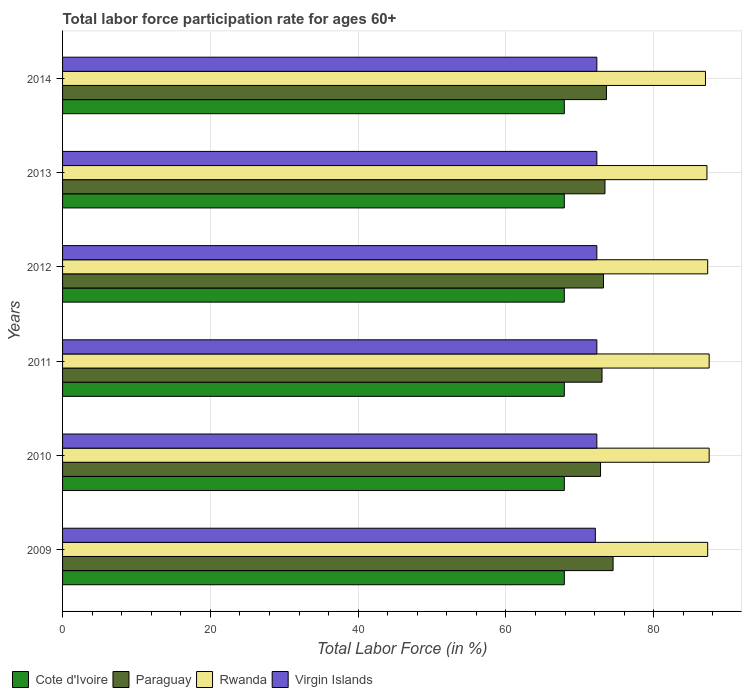Are the number of bars per tick equal to the number of legend labels?
Provide a succinct answer. Yes. Are the number of bars on each tick of the Y-axis equal?
Your answer should be very brief. Yes. In how many cases, is the number of bars for a given year not equal to the number of legend labels?
Give a very brief answer. 0. What is the labor force participation rate in Virgin Islands in 2011?
Your response must be concise. 72.3. Across all years, what is the maximum labor force participation rate in Rwanda?
Provide a short and direct response. 87.5. Across all years, what is the minimum labor force participation rate in Paraguay?
Your answer should be very brief. 72.8. In which year was the labor force participation rate in Virgin Islands maximum?
Provide a succinct answer. 2010. What is the total labor force participation rate in Cote d'Ivoire in the graph?
Your answer should be very brief. 407.4. What is the difference between the labor force participation rate in Cote d'Ivoire in 2009 and that in 2012?
Your response must be concise. 0. What is the difference between the labor force participation rate in Cote d'Ivoire in 2010 and the labor force participation rate in Rwanda in 2012?
Make the answer very short. -19.4. What is the average labor force participation rate in Virgin Islands per year?
Your answer should be compact. 72.27. In the year 2011, what is the difference between the labor force participation rate in Cote d'Ivoire and labor force participation rate in Paraguay?
Provide a short and direct response. -5.1. In how many years, is the labor force participation rate in Cote d'Ivoire greater than 8 %?
Make the answer very short. 6. What is the ratio of the labor force participation rate in Rwanda in 2012 to that in 2014?
Your answer should be compact. 1. What is the difference between the highest and the lowest labor force participation rate in Cote d'Ivoire?
Provide a short and direct response. 0. In how many years, is the labor force participation rate in Virgin Islands greater than the average labor force participation rate in Virgin Islands taken over all years?
Provide a succinct answer. 5. Is the sum of the labor force participation rate in Virgin Islands in 2010 and 2013 greater than the maximum labor force participation rate in Rwanda across all years?
Give a very brief answer. Yes. What does the 2nd bar from the top in 2014 represents?
Offer a very short reply. Rwanda. What does the 1st bar from the bottom in 2010 represents?
Keep it short and to the point. Cote d'Ivoire. Is it the case that in every year, the sum of the labor force participation rate in Cote d'Ivoire and labor force participation rate in Paraguay is greater than the labor force participation rate in Virgin Islands?
Your answer should be compact. Yes. What is the difference between two consecutive major ticks on the X-axis?
Provide a succinct answer. 20. Are the values on the major ticks of X-axis written in scientific E-notation?
Your answer should be very brief. No. Does the graph contain any zero values?
Make the answer very short. No. Where does the legend appear in the graph?
Your answer should be compact. Bottom left. What is the title of the graph?
Your answer should be compact. Total labor force participation rate for ages 60+. What is the label or title of the X-axis?
Give a very brief answer. Total Labor Force (in %). What is the label or title of the Y-axis?
Ensure brevity in your answer.  Years. What is the Total Labor Force (in %) in Cote d'Ivoire in 2009?
Your answer should be very brief. 67.9. What is the Total Labor Force (in %) of Paraguay in 2009?
Provide a succinct answer. 74.5. What is the Total Labor Force (in %) in Rwanda in 2009?
Offer a terse response. 87.3. What is the Total Labor Force (in %) of Virgin Islands in 2009?
Offer a very short reply. 72.1. What is the Total Labor Force (in %) in Cote d'Ivoire in 2010?
Keep it short and to the point. 67.9. What is the Total Labor Force (in %) of Paraguay in 2010?
Your answer should be very brief. 72.8. What is the Total Labor Force (in %) of Rwanda in 2010?
Your response must be concise. 87.5. What is the Total Labor Force (in %) of Virgin Islands in 2010?
Your answer should be compact. 72.3. What is the Total Labor Force (in %) of Cote d'Ivoire in 2011?
Provide a short and direct response. 67.9. What is the Total Labor Force (in %) of Rwanda in 2011?
Your answer should be compact. 87.5. What is the Total Labor Force (in %) of Virgin Islands in 2011?
Your response must be concise. 72.3. What is the Total Labor Force (in %) in Cote d'Ivoire in 2012?
Offer a very short reply. 67.9. What is the Total Labor Force (in %) of Paraguay in 2012?
Your answer should be very brief. 73.2. What is the Total Labor Force (in %) of Rwanda in 2012?
Offer a very short reply. 87.3. What is the Total Labor Force (in %) of Virgin Islands in 2012?
Keep it short and to the point. 72.3. What is the Total Labor Force (in %) in Cote d'Ivoire in 2013?
Keep it short and to the point. 67.9. What is the Total Labor Force (in %) of Paraguay in 2013?
Provide a succinct answer. 73.4. What is the Total Labor Force (in %) in Rwanda in 2013?
Ensure brevity in your answer.  87.2. What is the Total Labor Force (in %) of Virgin Islands in 2013?
Offer a terse response. 72.3. What is the Total Labor Force (in %) of Cote d'Ivoire in 2014?
Your response must be concise. 67.9. What is the Total Labor Force (in %) in Paraguay in 2014?
Your answer should be very brief. 73.6. What is the Total Labor Force (in %) of Rwanda in 2014?
Offer a terse response. 87. What is the Total Labor Force (in %) of Virgin Islands in 2014?
Your answer should be very brief. 72.3. Across all years, what is the maximum Total Labor Force (in %) in Cote d'Ivoire?
Your response must be concise. 67.9. Across all years, what is the maximum Total Labor Force (in %) of Paraguay?
Make the answer very short. 74.5. Across all years, what is the maximum Total Labor Force (in %) of Rwanda?
Give a very brief answer. 87.5. Across all years, what is the maximum Total Labor Force (in %) of Virgin Islands?
Your response must be concise. 72.3. Across all years, what is the minimum Total Labor Force (in %) in Cote d'Ivoire?
Offer a very short reply. 67.9. Across all years, what is the minimum Total Labor Force (in %) in Paraguay?
Provide a short and direct response. 72.8. Across all years, what is the minimum Total Labor Force (in %) in Virgin Islands?
Your answer should be very brief. 72.1. What is the total Total Labor Force (in %) in Cote d'Ivoire in the graph?
Keep it short and to the point. 407.4. What is the total Total Labor Force (in %) in Paraguay in the graph?
Your answer should be very brief. 440.5. What is the total Total Labor Force (in %) in Rwanda in the graph?
Keep it short and to the point. 523.8. What is the total Total Labor Force (in %) of Virgin Islands in the graph?
Provide a short and direct response. 433.6. What is the difference between the Total Labor Force (in %) in Cote d'Ivoire in 2009 and that in 2010?
Keep it short and to the point. 0. What is the difference between the Total Labor Force (in %) in Paraguay in 2009 and that in 2010?
Give a very brief answer. 1.7. What is the difference between the Total Labor Force (in %) in Rwanda in 2009 and that in 2010?
Offer a very short reply. -0.2. What is the difference between the Total Labor Force (in %) in Virgin Islands in 2009 and that in 2010?
Give a very brief answer. -0.2. What is the difference between the Total Labor Force (in %) in Paraguay in 2009 and that in 2011?
Offer a very short reply. 1.5. What is the difference between the Total Labor Force (in %) of Rwanda in 2009 and that in 2011?
Keep it short and to the point. -0.2. What is the difference between the Total Labor Force (in %) in Virgin Islands in 2009 and that in 2012?
Provide a succinct answer. -0.2. What is the difference between the Total Labor Force (in %) of Rwanda in 2009 and that in 2013?
Give a very brief answer. 0.1. What is the difference between the Total Labor Force (in %) in Rwanda in 2009 and that in 2014?
Give a very brief answer. 0.3. What is the difference between the Total Labor Force (in %) in Rwanda in 2010 and that in 2011?
Make the answer very short. 0. What is the difference between the Total Labor Force (in %) in Virgin Islands in 2010 and that in 2011?
Your response must be concise. 0. What is the difference between the Total Labor Force (in %) in Cote d'Ivoire in 2010 and that in 2012?
Give a very brief answer. 0. What is the difference between the Total Labor Force (in %) of Paraguay in 2010 and that in 2012?
Provide a succinct answer. -0.4. What is the difference between the Total Labor Force (in %) in Virgin Islands in 2010 and that in 2012?
Keep it short and to the point. 0. What is the difference between the Total Labor Force (in %) of Paraguay in 2010 and that in 2013?
Offer a terse response. -0.6. What is the difference between the Total Labor Force (in %) in Rwanda in 2010 and that in 2013?
Your response must be concise. 0.3. What is the difference between the Total Labor Force (in %) in Cote d'Ivoire in 2010 and that in 2014?
Ensure brevity in your answer.  0. What is the difference between the Total Labor Force (in %) in Paraguay in 2011 and that in 2012?
Ensure brevity in your answer.  -0.2. What is the difference between the Total Labor Force (in %) in Virgin Islands in 2011 and that in 2012?
Keep it short and to the point. 0. What is the difference between the Total Labor Force (in %) of Rwanda in 2011 and that in 2013?
Ensure brevity in your answer.  0.3. What is the difference between the Total Labor Force (in %) of Virgin Islands in 2011 and that in 2013?
Make the answer very short. 0. What is the difference between the Total Labor Force (in %) of Paraguay in 2011 and that in 2014?
Provide a succinct answer. -0.6. What is the difference between the Total Labor Force (in %) in Cote d'Ivoire in 2012 and that in 2013?
Make the answer very short. 0. What is the difference between the Total Labor Force (in %) in Cote d'Ivoire in 2012 and that in 2014?
Provide a short and direct response. 0. What is the difference between the Total Labor Force (in %) of Rwanda in 2012 and that in 2014?
Make the answer very short. 0.3. What is the difference between the Total Labor Force (in %) in Virgin Islands in 2012 and that in 2014?
Your answer should be compact. 0. What is the difference between the Total Labor Force (in %) of Cote d'Ivoire in 2013 and that in 2014?
Give a very brief answer. 0. What is the difference between the Total Labor Force (in %) of Rwanda in 2013 and that in 2014?
Make the answer very short. 0.2. What is the difference between the Total Labor Force (in %) in Cote d'Ivoire in 2009 and the Total Labor Force (in %) in Rwanda in 2010?
Offer a very short reply. -19.6. What is the difference between the Total Labor Force (in %) of Cote d'Ivoire in 2009 and the Total Labor Force (in %) of Virgin Islands in 2010?
Your answer should be compact. -4.4. What is the difference between the Total Labor Force (in %) in Paraguay in 2009 and the Total Labor Force (in %) in Rwanda in 2010?
Ensure brevity in your answer.  -13. What is the difference between the Total Labor Force (in %) in Rwanda in 2009 and the Total Labor Force (in %) in Virgin Islands in 2010?
Make the answer very short. 15. What is the difference between the Total Labor Force (in %) of Cote d'Ivoire in 2009 and the Total Labor Force (in %) of Rwanda in 2011?
Your answer should be compact. -19.6. What is the difference between the Total Labor Force (in %) of Paraguay in 2009 and the Total Labor Force (in %) of Rwanda in 2011?
Ensure brevity in your answer.  -13. What is the difference between the Total Labor Force (in %) of Paraguay in 2009 and the Total Labor Force (in %) of Virgin Islands in 2011?
Offer a very short reply. 2.2. What is the difference between the Total Labor Force (in %) in Cote d'Ivoire in 2009 and the Total Labor Force (in %) in Rwanda in 2012?
Provide a succinct answer. -19.4. What is the difference between the Total Labor Force (in %) of Cote d'Ivoire in 2009 and the Total Labor Force (in %) of Virgin Islands in 2012?
Make the answer very short. -4.4. What is the difference between the Total Labor Force (in %) in Cote d'Ivoire in 2009 and the Total Labor Force (in %) in Rwanda in 2013?
Provide a short and direct response. -19.3. What is the difference between the Total Labor Force (in %) of Paraguay in 2009 and the Total Labor Force (in %) of Rwanda in 2013?
Provide a short and direct response. -12.7. What is the difference between the Total Labor Force (in %) in Rwanda in 2009 and the Total Labor Force (in %) in Virgin Islands in 2013?
Your response must be concise. 15. What is the difference between the Total Labor Force (in %) in Cote d'Ivoire in 2009 and the Total Labor Force (in %) in Rwanda in 2014?
Provide a short and direct response. -19.1. What is the difference between the Total Labor Force (in %) of Paraguay in 2009 and the Total Labor Force (in %) of Rwanda in 2014?
Ensure brevity in your answer.  -12.5. What is the difference between the Total Labor Force (in %) of Cote d'Ivoire in 2010 and the Total Labor Force (in %) of Paraguay in 2011?
Offer a terse response. -5.1. What is the difference between the Total Labor Force (in %) of Cote d'Ivoire in 2010 and the Total Labor Force (in %) of Rwanda in 2011?
Ensure brevity in your answer.  -19.6. What is the difference between the Total Labor Force (in %) of Paraguay in 2010 and the Total Labor Force (in %) of Rwanda in 2011?
Provide a short and direct response. -14.7. What is the difference between the Total Labor Force (in %) of Paraguay in 2010 and the Total Labor Force (in %) of Virgin Islands in 2011?
Your answer should be compact. 0.5. What is the difference between the Total Labor Force (in %) in Cote d'Ivoire in 2010 and the Total Labor Force (in %) in Rwanda in 2012?
Offer a very short reply. -19.4. What is the difference between the Total Labor Force (in %) in Cote d'Ivoire in 2010 and the Total Labor Force (in %) in Virgin Islands in 2012?
Your answer should be very brief. -4.4. What is the difference between the Total Labor Force (in %) of Paraguay in 2010 and the Total Labor Force (in %) of Rwanda in 2012?
Your answer should be compact. -14.5. What is the difference between the Total Labor Force (in %) in Cote d'Ivoire in 2010 and the Total Labor Force (in %) in Rwanda in 2013?
Keep it short and to the point. -19.3. What is the difference between the Total Labor Force (in %) of Paraguay in 2010 and the Total Labor Force (in %) of Rwanda in 2013?
Keep it short and to the point. -14.4. What is the difference between the Total Labor Force (in %) of Rwanda in 2010 and the Total Labor Force (in %) of Virgin Islands in 2013?
Ensure brevity in your answer.  15.2. What is the difference between the Total Labor Force (in %) of Cote d'Ivoire in 2010 and the Total Labor Force (in %) of Paraguay in 2014?
Give a very brief answer. -5.7. What is the difference between the Total Labor Force (in %) in Cote d'Ivoire in 2010 and the Total Labor Force (in %) in Rwanda in 2014?
Give a very brief answer. -19.1. What is the difference between the Total Labor Force (in %) in Cote d'Ivoire in 2010 and the Total Labor Force (in %) in Virgin Islands in 2014?
Provide a succinct answer. -4.4. What is the difference between the Total Labor Force (in %) in Paraguay in 2010 and the Total Labor Force (in %) in Rwanda in 2014?
Offer a terse response. -14.2. What is the difference between the Total Labor Force (in %) of Cote d'Ivoire in 2011 and the Total Labor Force (in %) of Paraguay in 2012?
Ensure brevity in your answer.  -5.3. What is the difference between the Total Labor Force (in %) of Cote d'Ivoire in 2011 and the Total Labor Force (in %) of Rwanda in 2012?
Your answer should be compact. -19.4. What is the difference between the Total Labor Force (in %) in Cote d'Ivoire in 2011 and the Total Labor Force (in %) in Virgin Islands in 2012?
Offer a terse response. -4.4. What is the difference between the Total Labor Force (in %) in Paraguay in 2011 and the Total Labor Force (in %) in Rwanda in 2012?
Your answer should be very brief. -14.3. What is the difference between the Total Labor Force (in %) in Rwanda in 2011 and the Total Labor Force (in %) in Virgin Islands in 2012?
Keep it short and to the point. 15.2. What is the difference between the Total Labor Force (in %) in Cote d'Ivoire in 2011 and the Total Labor Force (in %) in Rwanda in 2013?
Provide a succinct answer. -19.3. What is the difference between the Total Labor Force (in %) of Paraguay in 2011 and the Total Labor Force (in %) of Rwanda in 2013?
Offer a terse response. -14.2. What is the difference between the Total Labor Force (in %) of Paraguay in 2011 and the Total Labor Force (in %) of Virgin Islands in 2013?
Ensure brevity in your answer.  0.7. What is the difference between the Total Labor Force (in %) in Cote d'Ivoire in 2011 and the Total Labor Force (in %) in Rwanda in 2014?
Provide a succinct answer. -19.1. What is the difference between the Total Labor Force (in %) of Cote d'Ivoire in 2011 and the Total Labor Force (in %) of Virgin Islands in 2014?
Make the answer very short. -4.4. What is the difference between the Total Labor Force (in %) in Rwanda in 2011 and the Total Labor Force (in %) in Virgin Islands in 2014?
Offer a very short reply. 15.2. What is the difference between the Total Labor Force (in %) of Cote d'Ivoire in 2012 and the Total Labor Force (in %) of Paraguay in 2013?
Provide a succinct answer. -5.5. What is the difference between the Total Labor Force (in %) of Cote d'Ivoire in 2012 and the Total Labor Force (in %) of Rwanda in 2013?
Your answer should be very brief. -19.3. What is the difference between the Total Labor Force (in %) in Paraguay in 2012 and the Total Labor Force (in %) in Virgin Islands in 2013?
Provide a succinct answer. 0.9. What is the difference between the Total Labor Force (in %) in Cote d'Ivoire in 2012 and the Total Labor Force (in %) in Paraguay in 2014?
Provide a short and direct response. -5.7. What is the difference between the Total Labor Force (in %) in Cote d'Ivoire in 2012 and the Total Labor Force (in %) in Rwanda in 2014?
Your response must be concise. -19.1. What is the difference between the Total Labor Force (in %) of Paraguay in 2012 and the Total Labor Force (in %) of Rwanda in 2014?
Keep it short and to the point. -13.8. What is the difference between the Total Labor Force (in %) of Paraguay in 2012 and the Total Labor Force (in %) of Virgin Islands in 2014?
Offer a very short reply. 0.9. What is the difference between the Total Labor Force (in %) of Rwanda in 2012 and the Total Labor Force (in %) of Virgin Islands in 2014?
Make the answer very short. 15. What is the difference between the Total Labor Force (in %) in Cote d'Ivoire in 2013 and the Total Labor Force (in %) in Rwanda in 2014?
Offer a very short reply. -19.1. What is the difference between the Total Labor Force (in %) of Rwanda in 2013 and the Total Labor Force (in %) of Virgin Islands in 2014?
Ensure brevity in your answer.  14.9. What is the average Total Labor Force (in %) in Cote d'Ivoire per year?
Your answer should be very brief. 67.9. What is the average Total Labor Force (in %) in Paraguay per year?
Your answer should be compact. 73.42. What is the average Total Labor Force (in %) in Rwanda per year?
Keep it short and to the point. 87.3. What is the average Total Labor Force (in %) of Virgin Islands per year?
Make the answer very short. 72.27. In the year 2009, what is the difference between the Total Labor Force (in %) in Cote d'Ivoire and Total Labor Force (in %) in Rwanda?
Provide a succinct answer. -19.4. In the year 2009, what is the difference between the Total Labor Force (in %) of Paraguay and Total Labor Force (in %) of Rwanda?
Ensure brevity in your answer.  -12.8. In the year 2009, what is the difference between the Total Labor Force (in %) of Rwanda and Total Labor Force (in %) of Virgin Islands?
Ensure brevity in your answer.  15.2. In the year 2010, what is the difference between the Total Labor Force (in %) in Cote d'Ivoire and Total Labor Force (in %) in Paraguay?
Your answer should be very brief. -4.9. In the year 2010, what is the difference between the Total Labor Force (in %) of Cote d'Ivoire and Total Labor Force (in %) of Rwanda?
Ensure brevity in your answer.  -19.6. In the year 2010, what is the difference between the Total Labor Force (in %) of Paraguay and Total Labor Force (in %) of Rwanda?
Make the answer very short. -14.7. In the year 2010, what is the difference between the Total Labor Force (in %) in Rwanda and Total Labor Force (in %) in Virgin Islands?
Provide a short and direct response. 15.2. In the year 2011, what is the difference between the Total Labor Force (in %) in Cote d'Ivoire and Total Labor Force (in %) in Paraguay?
Make the answer very short. -5.1. In the year 2011, what is the difference between the Total Labor Force (in %) in Cote d'Ivoire and Total Labor Force (in %) in Rwanda?
Make the answer very short. -19.6. In the year 2011, what is the difference between the Total Labor Force (in %) in Paraguay and Total Labor Force (in %) in Rwanda?
Keep it short and to the point. -14.5. In the year 2011, what is the difference between the Total Labor Force (in %) of Rwanda and Total Labor Force (in %) of Virgin Islands?
Ensure brevity in your answer.  15.2. In the year 2012, what is the difference between the Total Labor Force (in %) in Cote d'Ivoire and Total Labor Force (in %) in Rwanda?
Give a very brief answer. -19.4. In the year 2012, what is the difference between the Total Labor Force (in %) in Paraguay and Total Labor Force (in %) in Rwanda?
Provide a short and direct response. -14.1. In the year 2012, what is the difference between the Total Labor Force (in %) of Paraguay and Total Labor Force (in %) of Virgin Islands?
Your answer should be compact. 0.9. In the year 2013, what is the difference between the Total Labor Force (in %) of Cote d'Ivoire and Total Labor Force (in %) of Paraguay?
Keep it short and to the point. -5.5. In the year 2013, what is the difference between the Total Labor Force (in %) of Cote d'Ivoire and Total Labor Force (in %) of Rwanda?
Make the answer very short. -19.3. In the year 2013, what is the difference between the Total Labor Force (in %) in Paraguay and Total Labor Force (in %) in Rwanda?
Ensure brevity in your answer.  -13.8. In the year 2014, what is the difference between the Total Labor Force (in %) of Cote d'Ivoire and Total Labor Force (in %) of Rwanda?
Ensure brevity in your answer.  -19.1. In the year 2014, what is the difference between the Total Labor Force (in %) of Rwanda and Total Labor Force (in %) of Virgin Islands?
Ensure brevity in your answer.  14.7. What is the ratio of the Total Labor Force (in %) in Paraguay in 2009 to that in 2010?
Keep it short and to the point. 1.02. What is the ratio of the Total Labor Force (in %) in Rwanda in 2009 to that in 2010?
Give a very brief answer. 1. What is the ratio of the Total Labor Force (in %) in Cote d'Ivoire in 2009 to that in 2011?
Provide a succinct answer. 1. What is the ratio of the Total Labor Force (in %) in Paraguay in 2009 to that in 2011?
Provide a short and direct response. 1.02. What is the ratio of the Total Labor Force (in %) of Cote d'Ivoire in 2009 to that in 2012?
Keep it short and to the point. 1. What is the ratio of the Total Labor Force (in %) in Paraguay in 2009 to that in 2012?
Provide a short and direct response. 1.02. What is the ratio of the Total Labor Force (in %) in Rwanda in 2009 to that in 2012?
Your answer should be very brief. 1. What is the ratio of the Total Labor Force (in %) of Virgin Islands in 2009 to that in 2012?
Offer a terse response. 1. What is the ratio of the Total Labor Force (in %) of Cote d'Ivoire in 2009 to that in 2013?
Offer a very short reply. 1. What is the ratio of the Total Labor Force (in %) of Paraguay in 2009 to that in 2013?
Your answer should be compact. 1.01. What is the ratio of the Total Labor Force (in %) of Rwanda in 2009 to that in 2013?
Keep it short and to the point. 1. What is the ratio of the Total Labor Force (in %) in Virgin Islands in 2009 to that in 2013?
Your answer should be compact. 1. What is the ratio of the Total Labor Force (in %) in Cote d'Ivoire in 2009 to that in 2014?
Offer a terse response. 1. What is the ratio of the Total Labor Force (in %) in Paraguay in 2009 to that in 2014?
Make the answer very short. 1.01. What is the ratio of the Total Labor Force (in %) of Rwanda in 2009 to that in 2014?
Give a very brief answer. 1. What is the ratio of the Total Labor Force (in %) in Virgin Islands in 2010 to that in 2011?
Your answer should be compact. 1. What is the ratio of the Total Labor Force (in %) in Paraguay in 2010 to that in 2012?
Provide a succinct answer. 0.99. What is the ratio of the Total Labor Force (in %) of Rwanda in 2010 to that in 2012?
Provide a succinct answer. 1. What is the ratio of the Total Labor Force (in %) in Virgin Islands in 2010 to that in 2012?
Your answer should be compact. 1. What is the ratio of the Total Labor Force (in %) in Cote d'Ivoire in 2010 to that in 2013?
Ensure brevity in your answer.  1. What is the ratio of the Total Labor Force (in %) of Paraguay in 2010 to that in 2013?
Offer a terse response. 0.99. What is the ratio of the Total Labor Force (in %) in Virgin Islands in 2010 to that in 2013?
Keep it short and to the point. 1. What is the ratio of the Total Labor Force (in %) in Cote d'Ivoire in 2010 to that in 2014?
Give a very brief answer. 1. What is the ratio of the Total Labor Force (in %) of Paraguay in 2010 to that in 2014?
Your response must be concise. 0.99. What is the ratio of the Total Labor Force (in %) in Rwanda in 2010 to that in 2014?
Your answer should be very brief. 1.01. What is the ratio of the Total Labor Force (in %) in Cote d'Ivoire in 2011 to that in 2012?
Your answer should be very brief. 1. What is the ratio of the Total Labor Force (in %) in Paraguay in 2011 to that in 2012?
Offer a terse response. 1. What is the ratio of the Total Labor Force (in %) in Rwanda in 2011 to that in 2012?
Provide a short and direct response. 1. What is the ratio of the Total Labor Force (in %) in Virgin Islands in 2011 to that in 2012?
Provide a short and direct response. 1. What is the ratio of the Total Labor Force (in %) in Paraguay in 2011 to that in 2014?
Ensure brevity in your answer.  0.99. What is the ratio of the Total Labor Force (in %) of Rwanda in 2011 to that in 2014?
Give a very brief answer. 1.01. What is the ratio of the Total Labor Force (in %) in Cote d'Ivoire in 2012 to that in 2013?
Your answer should be very brief. 1. What is the ratio of the Total Labor Force (in %) in Rwanda in 2012 to that in 2013?
Provide a succinct answer. 1. What is the ratio of the Total Labor Force (in %) in Rwanda in 2012 to that in 2014?
Offer a very short reply. 1. What is the ratio of the Total Labor Force (in %) of Virgin Islands in 2012 to that in 2014?
Your answer should be compact. 1. What is the difference between the highest and the second highest Total Labor Force (in %) in Paraguay?
Offer a very short reply. 0.9. What is the difference between the highest and the second highest Total Labor Force (in %) of Rwanda?
Provide a short and direct response. 0. What is the difference between the highest and the second highest Total Labor Force (in %) in Virgin Islands?
Your answer should be very brief. 0. What is the difference between the highest and the lowest Total Labor Force (in %) of Virgin Islands?
Ensure brevity in your answer.  0.2. 